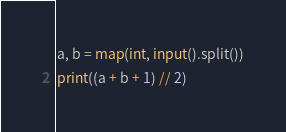<code> <loc_0><loc_0><loc_500><loc_500><_Python_>a, b = map(int, input().split())
print((a + b + 1) // 2)</code> 